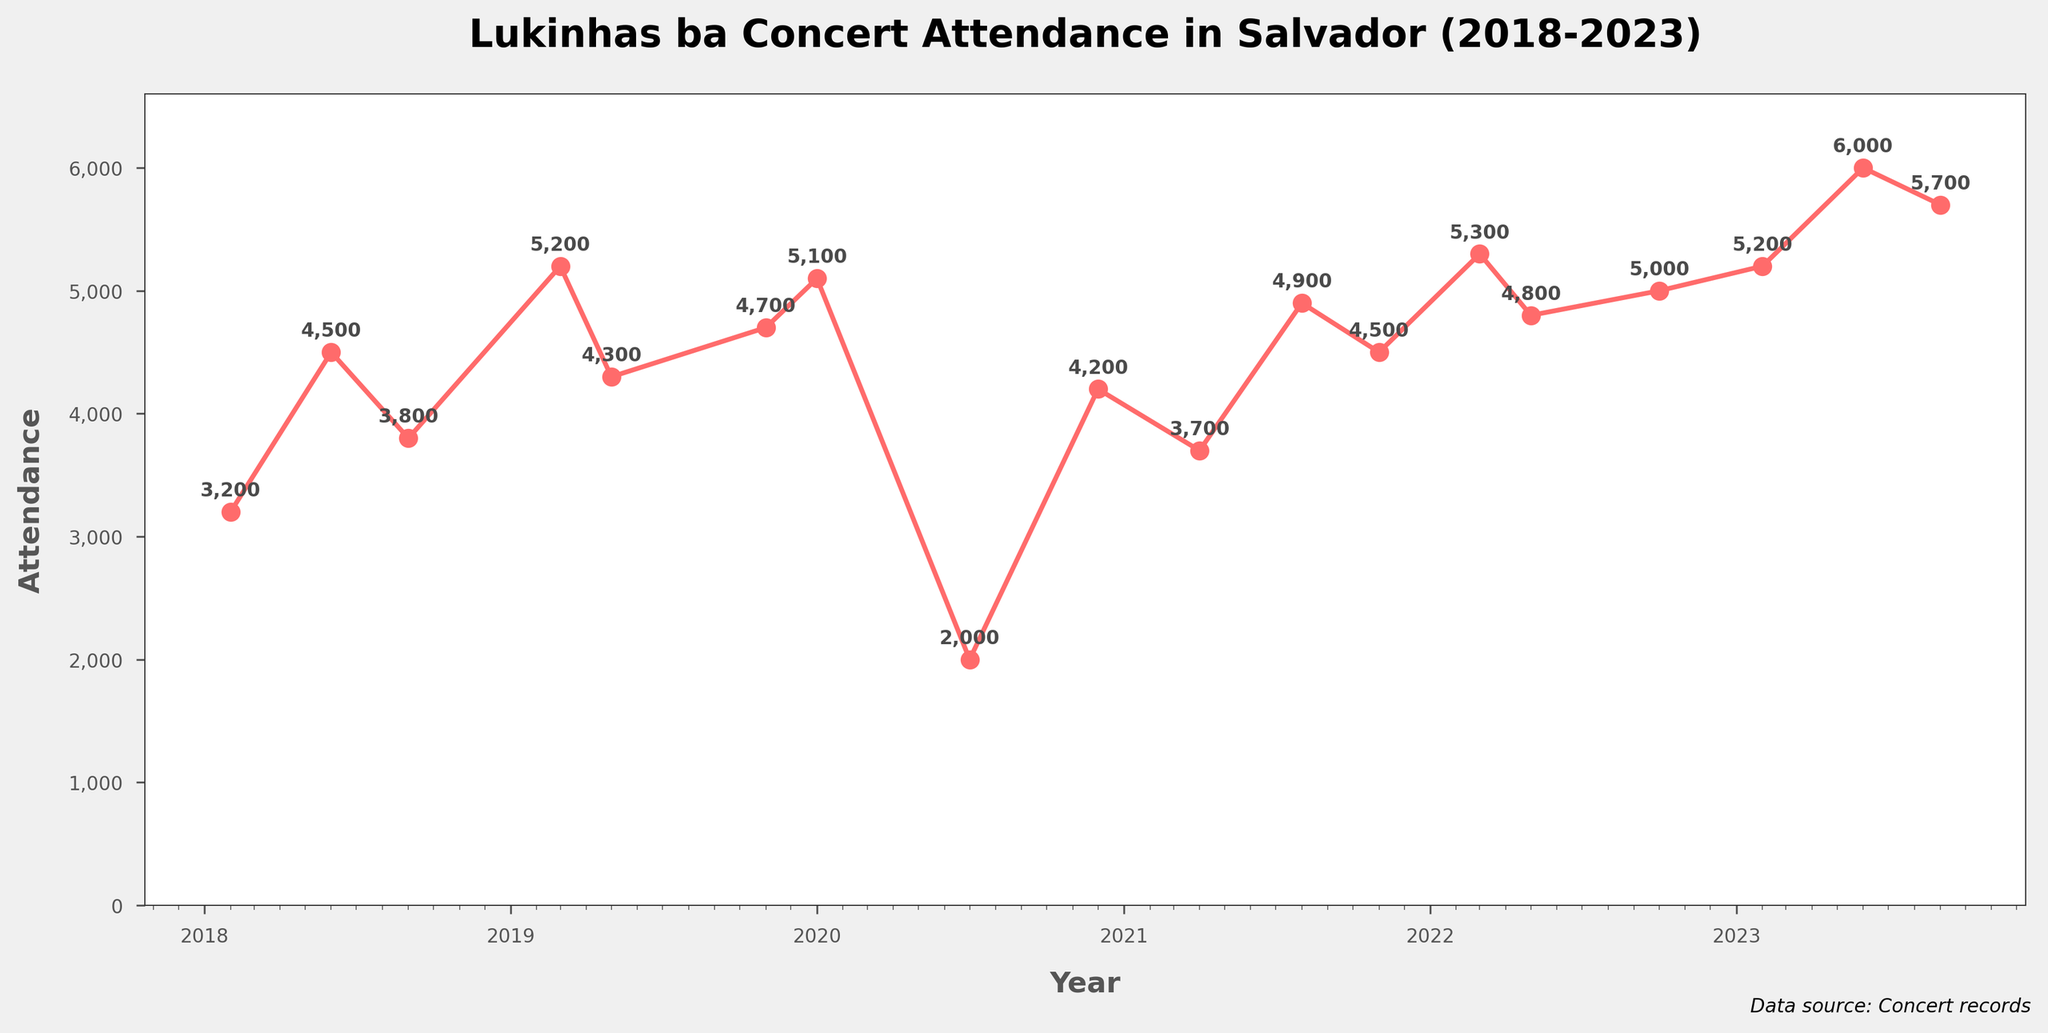What's the title of the plot? The title of the plot is written at the top in a bold and larger font compared to other text. It states the main subject of the plot. The title reads, "Lukinhas ba Concert Attendance in Salvador (2018-2023)."
Answer: Lukinhas ba Concert Attendance in Salvador (2018-2023) How many concerts did Lukinhas ba hold in 2019? To find the number of concerts Lukinhas ba held in 2019, locate the year 2019 on the x-axis and count the number of data points (markers) above it. There are two data points corresponding to 2019.
Answer: 2 What was the lowest attendance figure, and in which concert did this occur? To find the lowest attendance, find the point on the plot closest to the bottom of the y-axis. The lowest point corresponds to the "Virtual Home Concert" in July 2020 with an attendance of 2,000.
Answer: 2,000, Virtual Home Concert What is the difference in attendance between the highest and lowest attended concerts? The highest attendance is 6,000 (Festa Junina Celebration, June 2023), and the lowest is 2,000 (Virtual Home Concert, July 2020). To find the difference, subtract the lowest from the highest: 6,000 - 2,000.
Answer: 4,000 Which year showed the highest average concert attendance? Calculate the average attendance for each year by summing the attendance figures for the concerts in that year and dividing by the number of concerts. Compare these averages to find the highest. For instance, 2023 has 3 concerts with a total attendance of (5,200 + 6,000 + 5,700)/3 = 5,633.
Answer: 2023 How did the attendance trend change from 2020 to 2021? Compare the attendance figures for concerts in 2020 and 2021 by looking at the data points corresponding to those years. The attendance generally decreased in 2020 due to the pandemic, then started increasing in 2021.
Answer: Decreased in 2020, increased in 2021 Which concert had an attendance of exactly 5,200? Look for a data point labeled with the attendance figure 5,200 and check the concert name. It’s the "Bahia Carnival Special" in March 2019 and "Salvador Samba Night" in February 2023.
Answer: Bahia Carnival Special, March 2019, Salvador Samba Night, February 2023 What is the average attendance of all concerts held in February? Identify the concerts held in February (2018, 2023), sum their attendance figures (3,200 + 5,200) and divide by the number of concerts (2).
Answer: 4,200 Which month in 2018 had the highest concert attendance? Locate the data points for 2018 on the x-axis, and check their corresponding attendance values. The highest attendance in 2018 is 4,500 at "Festa Junina Salvador" in June.
Answer: June Which concert had a sharp increase in attendance compared to its previous concert in 2023? Identify concerts in 2023 and check for a significant rise from one data point to the next. There's a sharp increase from "Salvador Samba Night" in February (5,200) to "Festa Junina Celebration" in June (6,000).
Answer: Festa Junina Celebration, June 2023 